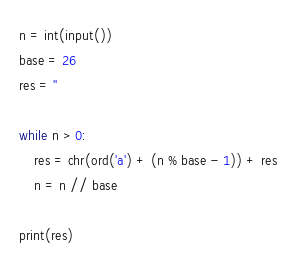<code> <loc_0><loc_0><loc_500><loc_500><_Python_>n = int(input())
base = 26
res = ''

while n > 0:
    res = chr(ord('a') + (n % base - 1)) + res
    n = n // base

print(res)</code> 